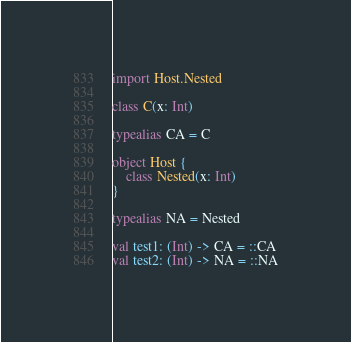<code> <loc_0><loc_0><loc_500><loc_500><_Kotlin_>import Host.Nested

class C(x: Int)

typealias CA = C

object Host {
    class Nested(x: Int)
}

typealias NA = Nested

val test1: (Int) -> CA = ::CA
val test2: (Int) -> NA = ::NA</code> 